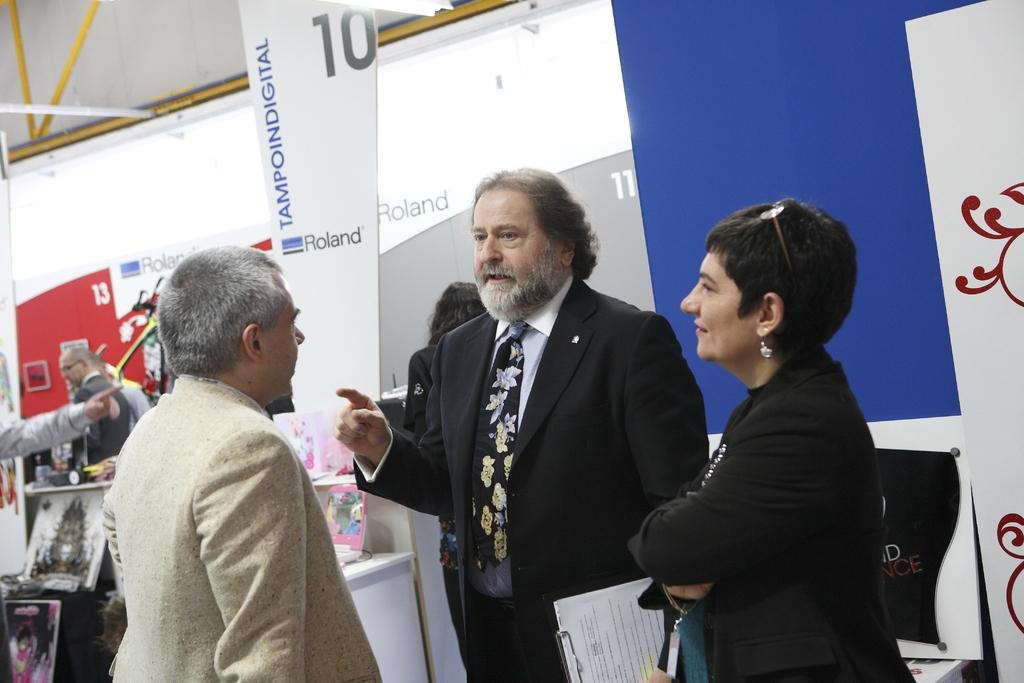What can be seen in the image? There are people standing in the image. What else is present in the image besides the people? There are posters in the image. What type of flag is being waved by the people in the image? There is no flag present in the image; only people and posters are visible. How many guns can be seen in the image? There are no guns present in the image. 